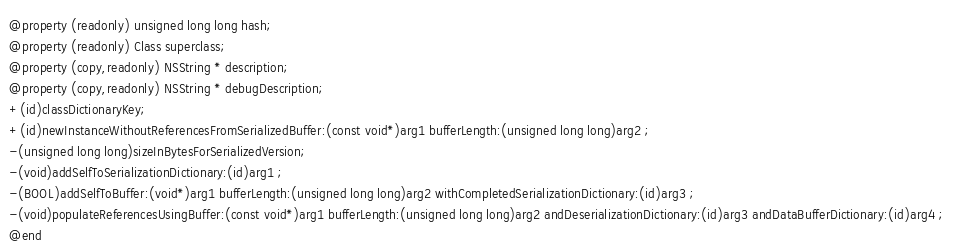<code> <loc_0><loc_0><loc_500><loc_500><_C_>@property (readonly) unsigned long long hash; 
@property (readonly) Class superclass; 
@property (copy,readonly) NSString * description; 
@property (copy,readonly) NSString * debugDescription; 
+(id)classDictionaryKey;
+(id)newInstanceWithoutReferencesFromSerializedBuffer:(const void*)arg1 bufferLength:(unsigned long long)arg2 ;
-(unsigned long long)sizeInBytesForSerializedVersion;
-(void)addSelfToSerializationDictionary:(id)arg1 ;
-(BOOL)addSelfToBuffer:(void*)arg1 bufferLength:(unsigned long long)arg2 withCompletedSerializationDictionary:(id)arg3 ;
-(void)populateReferencesUsingBuffer:(const void*)arg1 bufferLength:(unsigned long long)arg2 andDeserializationDictionary:(id)arg3 andDataBufferDictionary:(id)arg4 ;
@end

</code> 